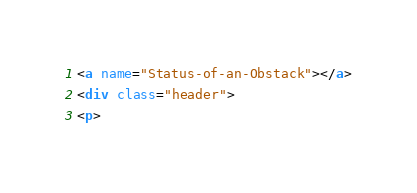<code> <loc_0><loc_0><loc_500><loc_500><_HTML_><a name="Status-of-an-Obstack"></a>
<div class="header">
<p></code> 